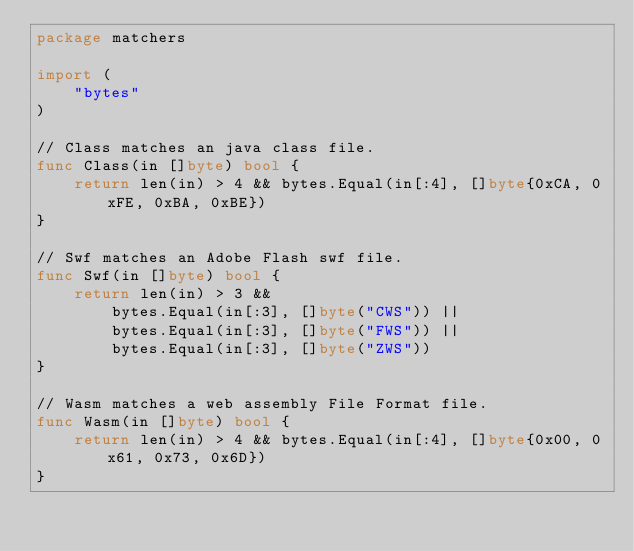<code> <loc_0><loc_0><loc_500><loc_500><_Go_>package matchers

import (
	"bytes"
)

// Class matches an java class file.
func Class(in []byte) bool {
	return len(in) > 4 && bytes.Equal(in[:4], []byte{0xCA, 0xFE, 0xBA, 0xBE})
}

// Swf matches an Adobe Flash swf file.
func Swf(in []byte) bool {
	return len(in) > 3 &&
		bytes.Equal(in[:3], []byte("CWS")) ||
		bytes.Equal(in[:3], []byte("FWS")) ||
		bytes.Equal(in[:3], []byte("ZWS"))
}

// Wasm matches a web assembly File Format file.
func Wasm(in []byte) bool {
	return len(in) > 4 && bytes.Equal(in[:4], []byte{0x00, 0x61, 0x73, 0x6D})
}
</code> 